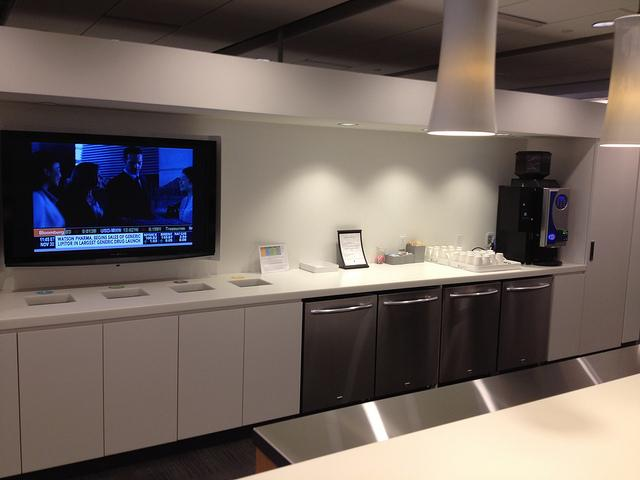What station is on the television? Please explain your reasoning. bloomberg. The screen says bloomberg. 